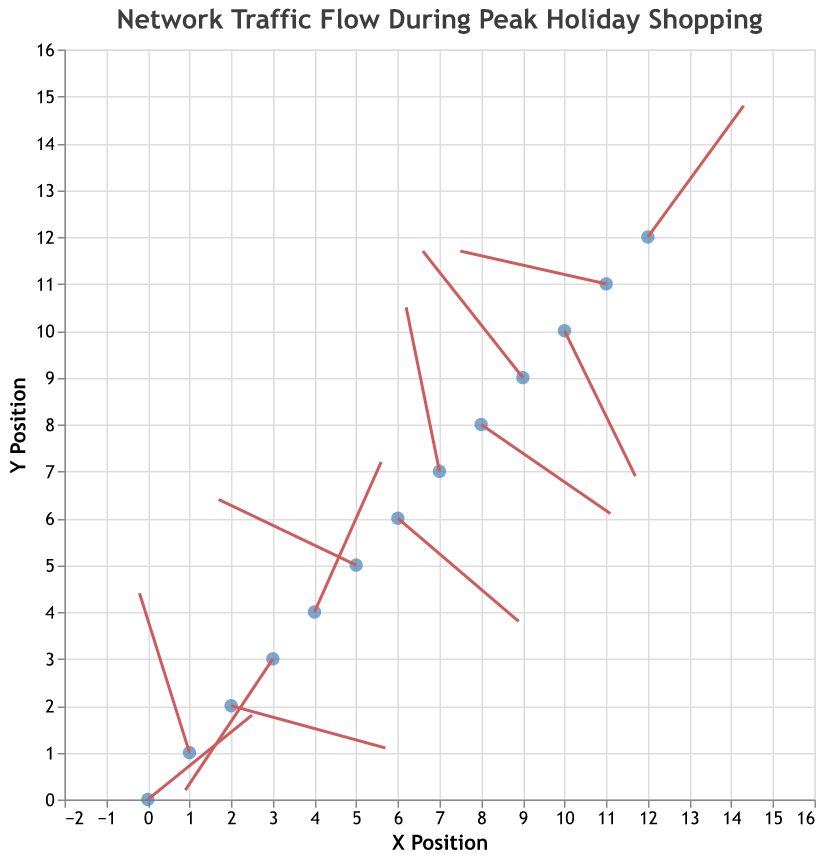What is the title of the figure? The title is located at the top of the figure and reads "Network Traffic Flow During Peak Holiday Shopping".
Answer: Network Traffic Flow During Peak Holiday Shopping How many data points are displayed in the quiver plot? Counting the points marked with filled circles from the visual representation, there are 13 data points in total.
Answer: 13 Which axis represents the X Position? The X Position is represented on the horizontal axis, as indicated by the axis title.
Answer: Horizontal axis What is the direction of the vector at point (1,1)? The vector starts at coordinate (1,1) and points to (-1.2+1, 3.4+1) which is (-0.2, 4.4), indicating a negative X direction and a positive Y direction.
Answer: Negative X, Positive Y Which point has the longest vector segment when measuring the magnitude? By comparing the vector magnitudes in the data, the point (2,2) with a magnitude of 3.8 has the longest vector segment.
Answer: Point (2,2) What are the beginning and end coordinates of the vector at point (4,4)? The vector starts at (4,4) and moves by (1.6, 3.2), so the end coordinates are (4+1.6, 4+3.2), which is (5.6,7.2).
Answer: (4,4) to (5.6,7.2) What is the average magnitude of all vectors in the plot? Summing up all magnitudes: 3.1 + 3.6 + 3.8 + 3.5 + 3.6 + 3.6 + 3.6 + 3.6 + 3.6 + 3.6 + 3.5 + 3.6 + 3.6 = 46.3; then dividing by 13: 46.3 / 13 = 3.56.
Answer: 3.56 Compare the vectors at points (6,6) and (8,8). Which vector has a greater magnitude? Looking at the magnitudes; vectors at (6,6) and (8,8) have magnitudes of 3.6 and 3.6 respectively. Both have equal magnitudes.
Answer: Equal What is the vector direction trend as we move from point (0,0) to point (12,12)? By observing the vectors' u and v values, directions alternate but show a general mixture of shifts among positive and negative X and Y directions without a clear increasing or decreasing trend.
Answer: Alternating directions Which vector at a specific point has a negative X and negative Y direction? Reviewing the vector components, the vector at point (3,3) moves to (-2.1, -2.8), indicating negative directions in both X and Y.
Answer: Point (3,3) 